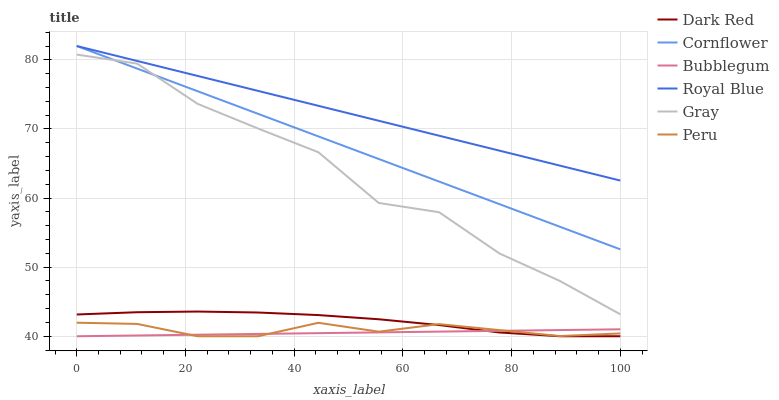Does Bubblegum have the minimum area under the curve?
Answer yes or no. Yes. Does Royal Blue have the maximum area under the curve?
Answer yes or no. Yes. Does Cornflower have the minimum area under the curve?
Answer yes or no. No. Does Cornflower have the maximum area under the curve?
Answer yes or no. No. Is Cornflower the smoothest?
Answer yes or no. Yes. Is Gray the roughest?
Answer yes or no. Yes. Is Dark Red the smoothest?
Answer yes or no. No. Is Dark Red the roughest?
Answer yes or no. No. Does Cornflower have the lowest value?
Answer yes or no. No. Does Royal Blue have the highest value?
Answer yes or no. Yes. Does Dark Red have the highest value?
Answer yes or no. No. Is Peru less than Gray?
Answer yes or no. Yes. Is Royal Blue greater than Gray?
Answer yes or no. Yes. Does Royal Blue intersect Cornflower?
Answer yes or no. Yes. Is Royal Blue less than Cornflower?
Answer yes or no. No. Is Royal Blue greater than Cornflower?
Answer yes or no. No. Does Peru intersect Gray?
Answer yes or no. No. 